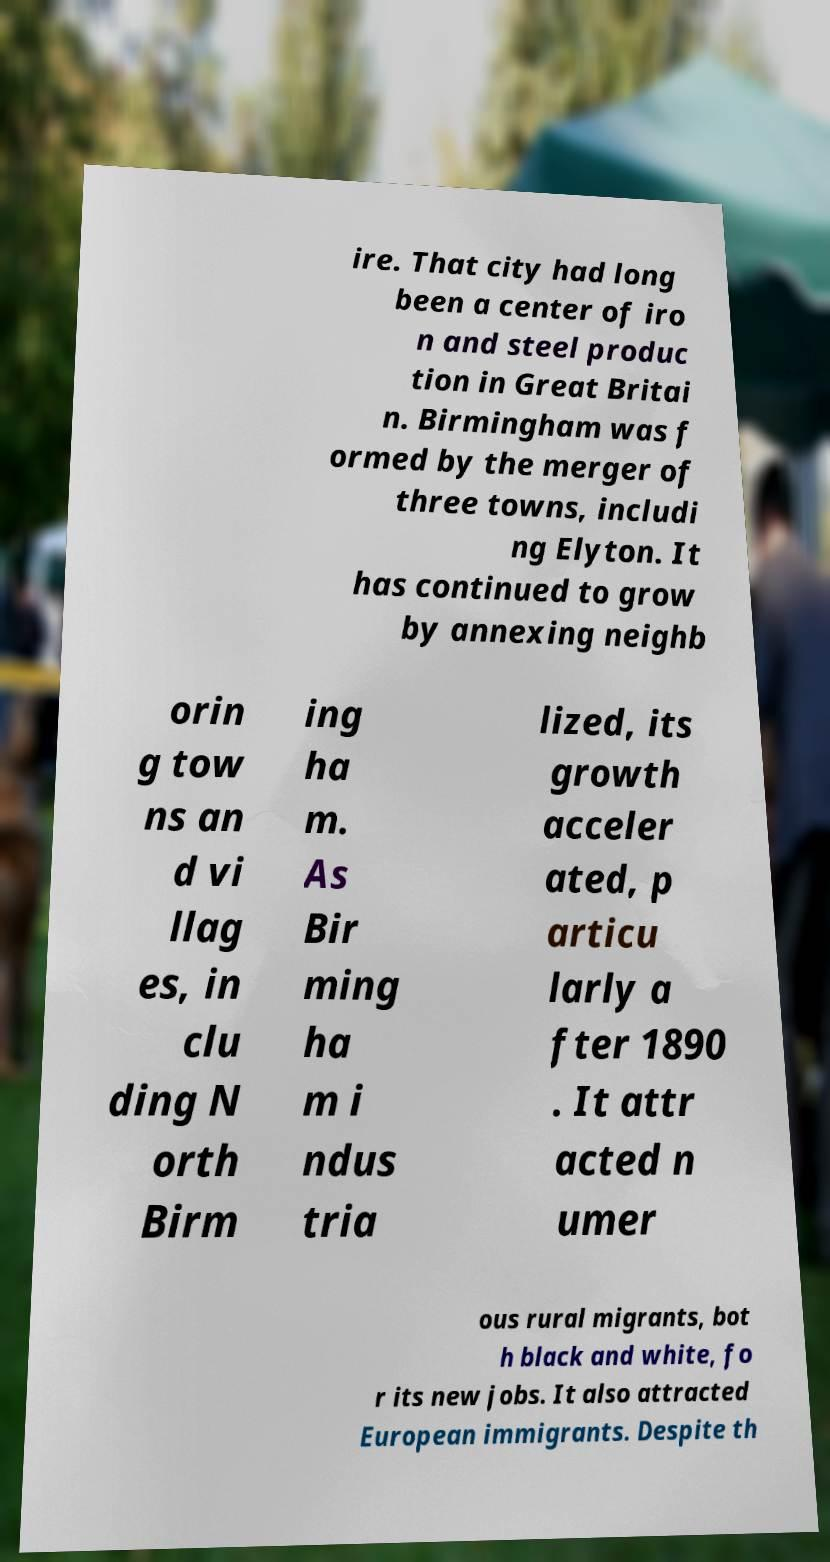There's text embedded in this image that I need extracted. Can you transcribe it verbatim? ire. That city had long been a center of iro n and steel produc tion in Great Britai n. Birmingham was f ormed by the merger of three towns, includi ng Elyton. It has continued to grow by annexing neighb orin g tow ns an d vi llag es, in clu ding N orth Birm ing ha m. As Bir ming ha m i ndus tria lized, its growth acceler ated, p articu larly a fter 1890 . It attr acted n umer ous rural migrants, bot h black and white, fo r its new jobs. It also attracted European immigrants. Despite th 